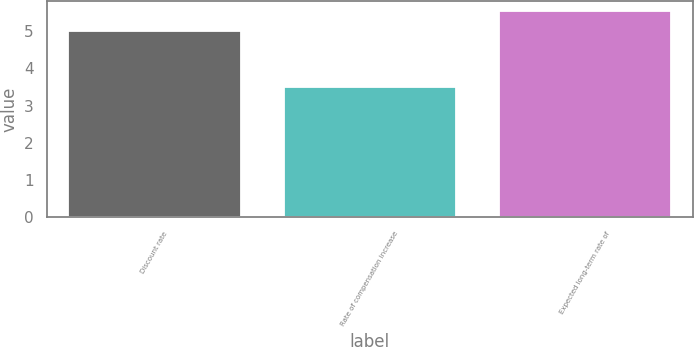Convert chart to OTSL. <chart><loc_0><loc_0><loc_500><loc_500><bar_chart><fcel>Discount rate<fcel>Rate of compensation increase<fcel>Expected long-term rate of<nl><fcel>5<fcel>3.5<fcel>5.52<nl></chart> 